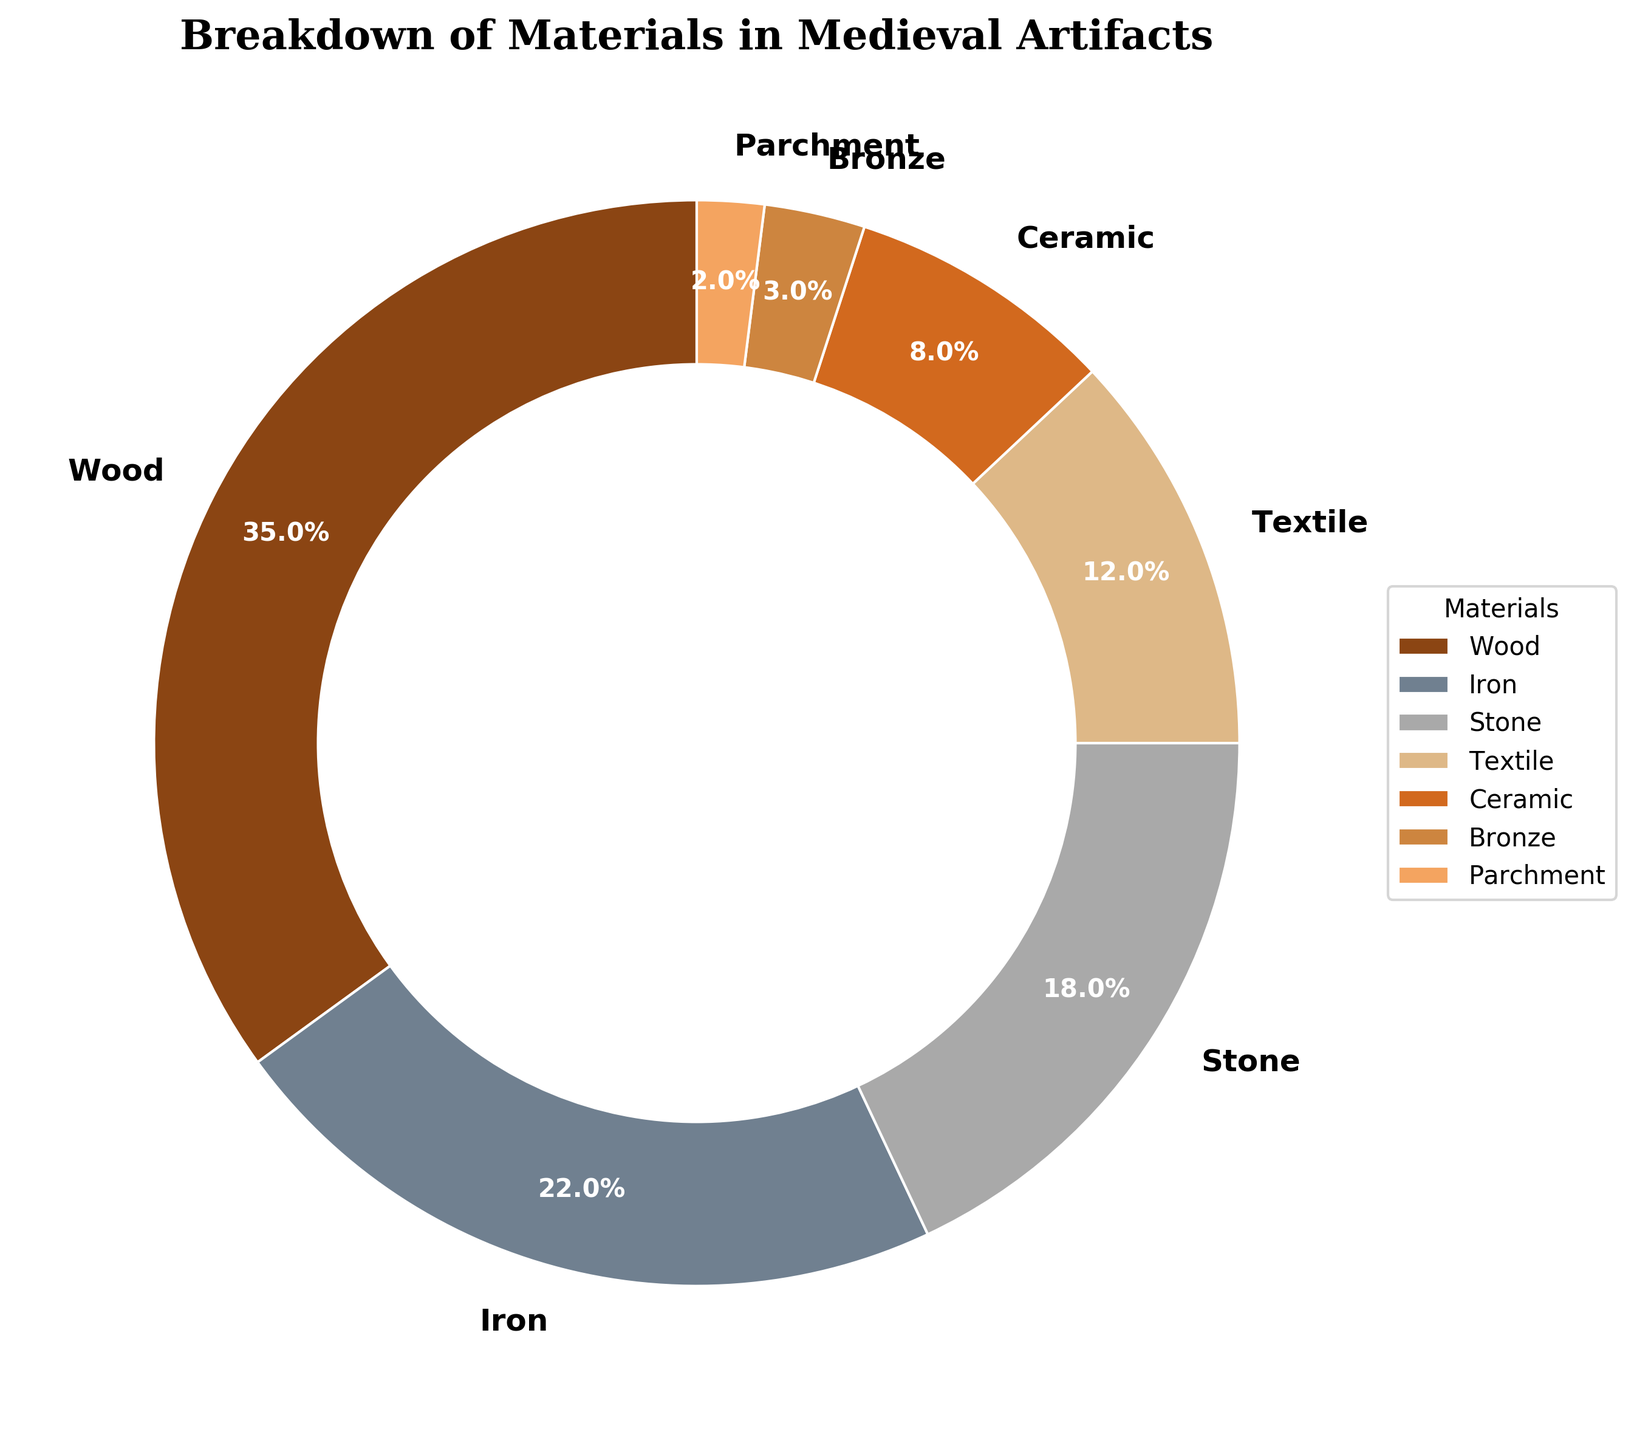What material makes up the largest percentage of medieval artifacts? By observing the pie chart, the segment representing "Wood" is the largest, occupying 35% of the chart.
Answer: Wood Which material makes up a smaller percentage of medieval artifacts: Iron or Textile? The pie chart shows that Iron occupies 22% while Textile occupies 12%. Since 12% is less than 22%, Textile makes up a smaller percentage.
Answer: Textile What is the combined percentage of Stone and Ceramic artifacts? According to the pie chart, Stone makes up 18% and Ceramic makes up 8%. Adding these two percentages together gives 18% + 8% = 26%.
Answer: 26% Compare the percentage of Bronze artifacts to that of Parchment artifacts. Which one is greater? From the pie chart, Bronze artifacts account for 3% while Parchment artifacts account for 2%. Since 3% is greater than 2%, Bronze is greater.
Answer: Bronze What is the difference in the percentage between Wood and Iron artifacts? Wood accounts for 35% and Iron accounts for 22%. The difference between them is 35% - 22% = 13%.
Answer: 13% How does the percentage of Textile artifacts compare to the combined percentage of Ceramic and Parchment artifacts? Textile artifacts account for 12%. The combined percentage of Ceramic (8%) and Parchment (2%) is 8% + 2% = 10%. Since 12% is greater than 10%, Textile is greater.
Answer: Textile Which material is represented by a segment between Bronze and Stone on the pie chart? The pie chart segments are arranged in a certain order. According to the chart, Textile (12%) lies between Bronze (3%) and Stone (18%).
Answer: Textile What visual characteristic identifies the segment representing Ceramic in the pie chart? In the pie chart, different materials are represented by distinct colors. The segment representing Ceramic is marked by a particular brownish color.
Answer: Brownish color Identify the material that accounts for the smallest percentage and mention the value. Observing the smallest segment of the pie chart, Parchment accounts for the smallest percentage at 2%.
Answer: Parchment, 2% What is the total percentage of all the materials except Wood and Iron? To find the total percentage of all materials except Wood (35%) and Iron (22%), sum the percentages of Stone (18%), Textile (12%), Ceramic (8%), Bronze (3%), and Parchment (2%). Therefore, the total is 18% + 12% + 8% + 3% + 2% = 43%.
Answer: 43% 